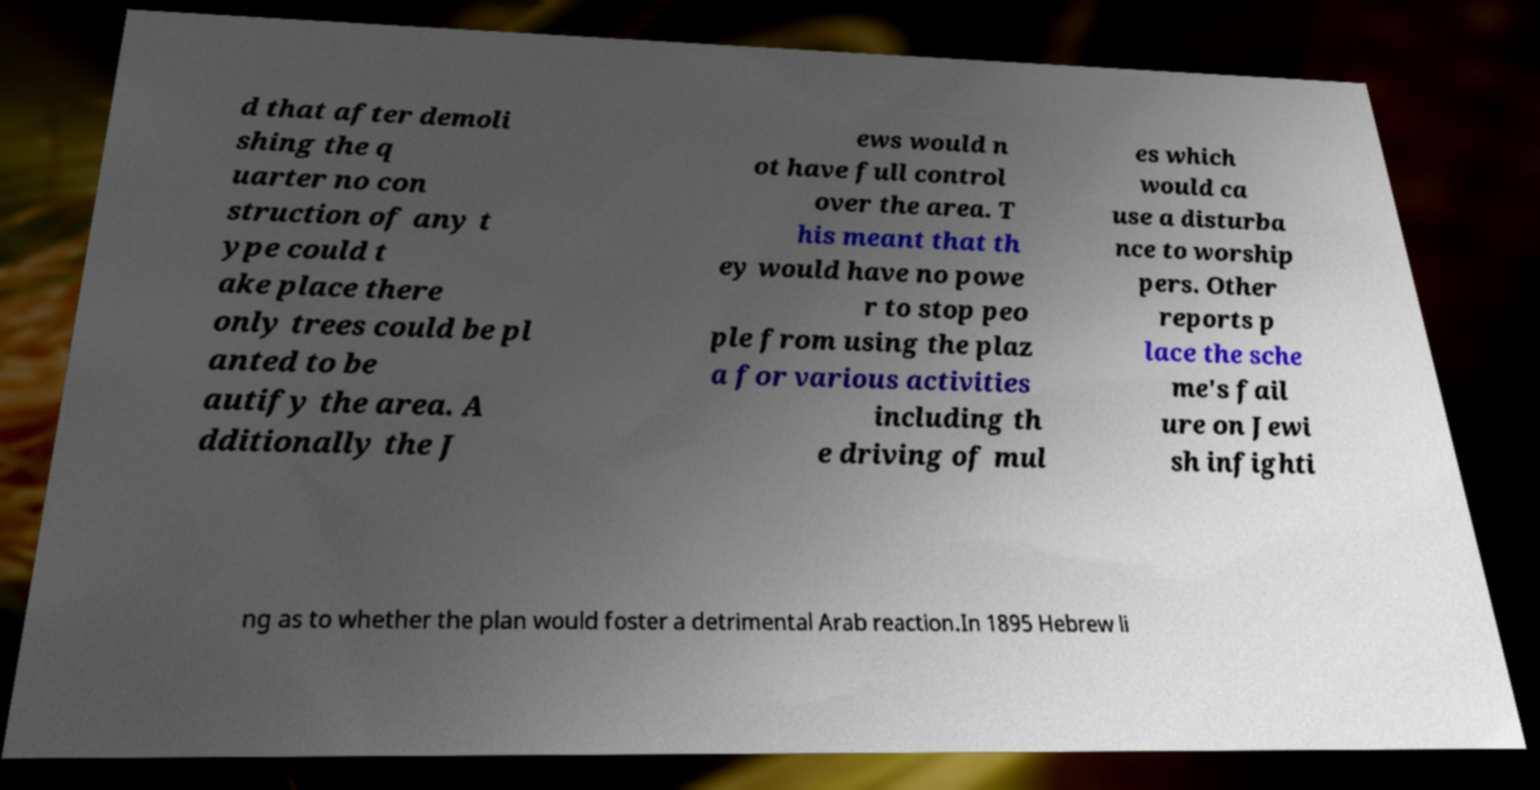Please read and relay the text visible in this image. What does it say? d that after demoli shing the q uarter no con struction of any t ype could t ake place there only trees could be pl anted to be autify the area. A dditionally the J ews would n ot have full control over the area. T his meant that th ey would have no powe r to stop peo ple from using the plaz a for various activities including th e driving of mul es which would ca use a disturba nce to worship pers. Other reports p lace the sche me's fail ure on Jewi sh infighti ng as to whether the plan would foster a detrimental Arab reaction.In 1895 Hebrew li 